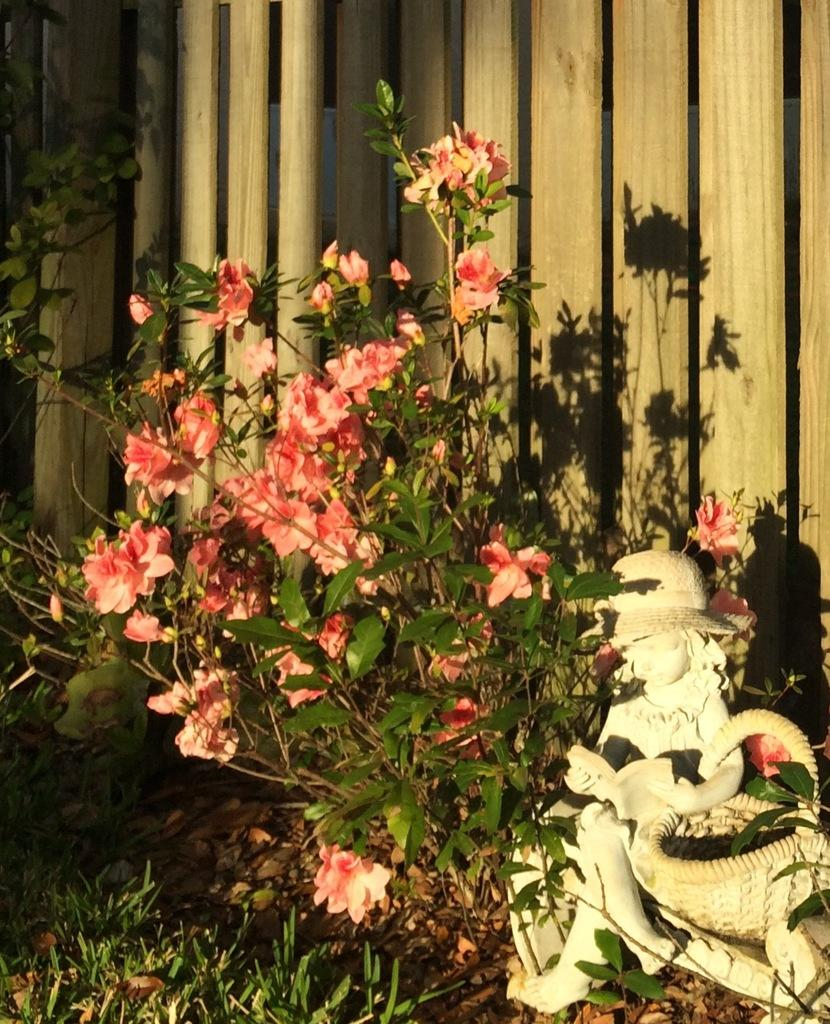What type of plant life is visible in the image? There are flowers and leaves of a plant in the image. What is located beside the plant? There is a statue beside the plant. What type of material is the wall behind the plant made of? The wall behind the plant is made of wood. What type of magic is being performed by the flowers in the image? There is no magic being performed by the flowers in the image; they are simply plants. 